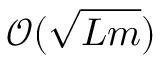Convert formula to latex. <formula><loc_0><loc_0><loc_500><loc_500>\mathcal { O } ( \sqrt { L m } )</formula> 